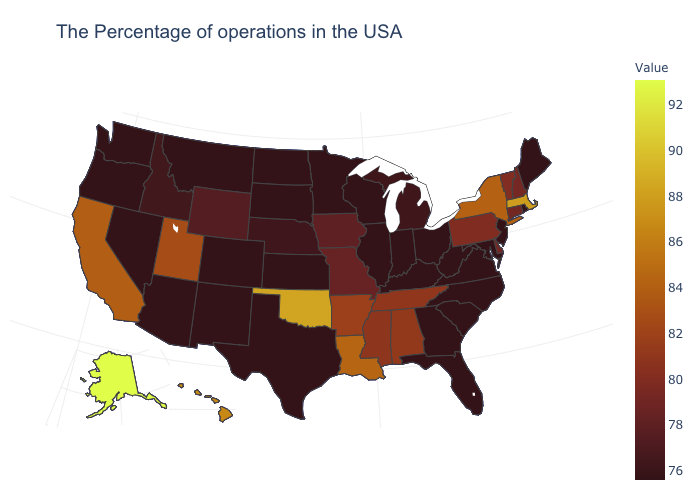Does New York have a higher value than Massachusetts?
Write a very short answer. No. Does Rhode Island have the highest value in the USA?
Answer briefly. No. Does New Jersey have the highest value in the Northeast?
Keep it brief. No. 